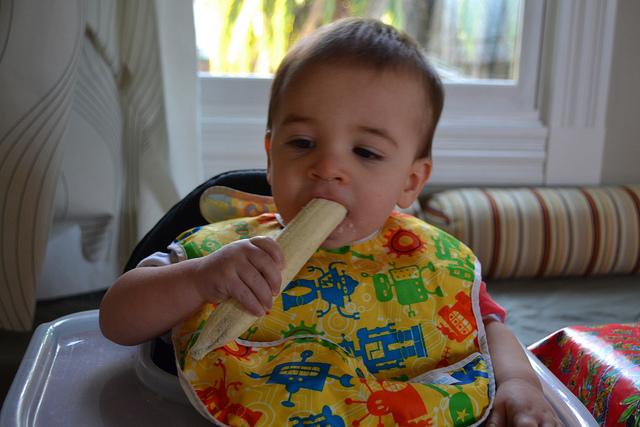What object is on the child's bib?
Be succinct. Robots. What does the baby have around his neck?
Keep it brief. Bib. What is the child eating?
Keep it brief. Banana. Does it appear to be morning or night?
Quick response, please. Morning. What is she holding in her mouth?
Concise answer only. Banana. 